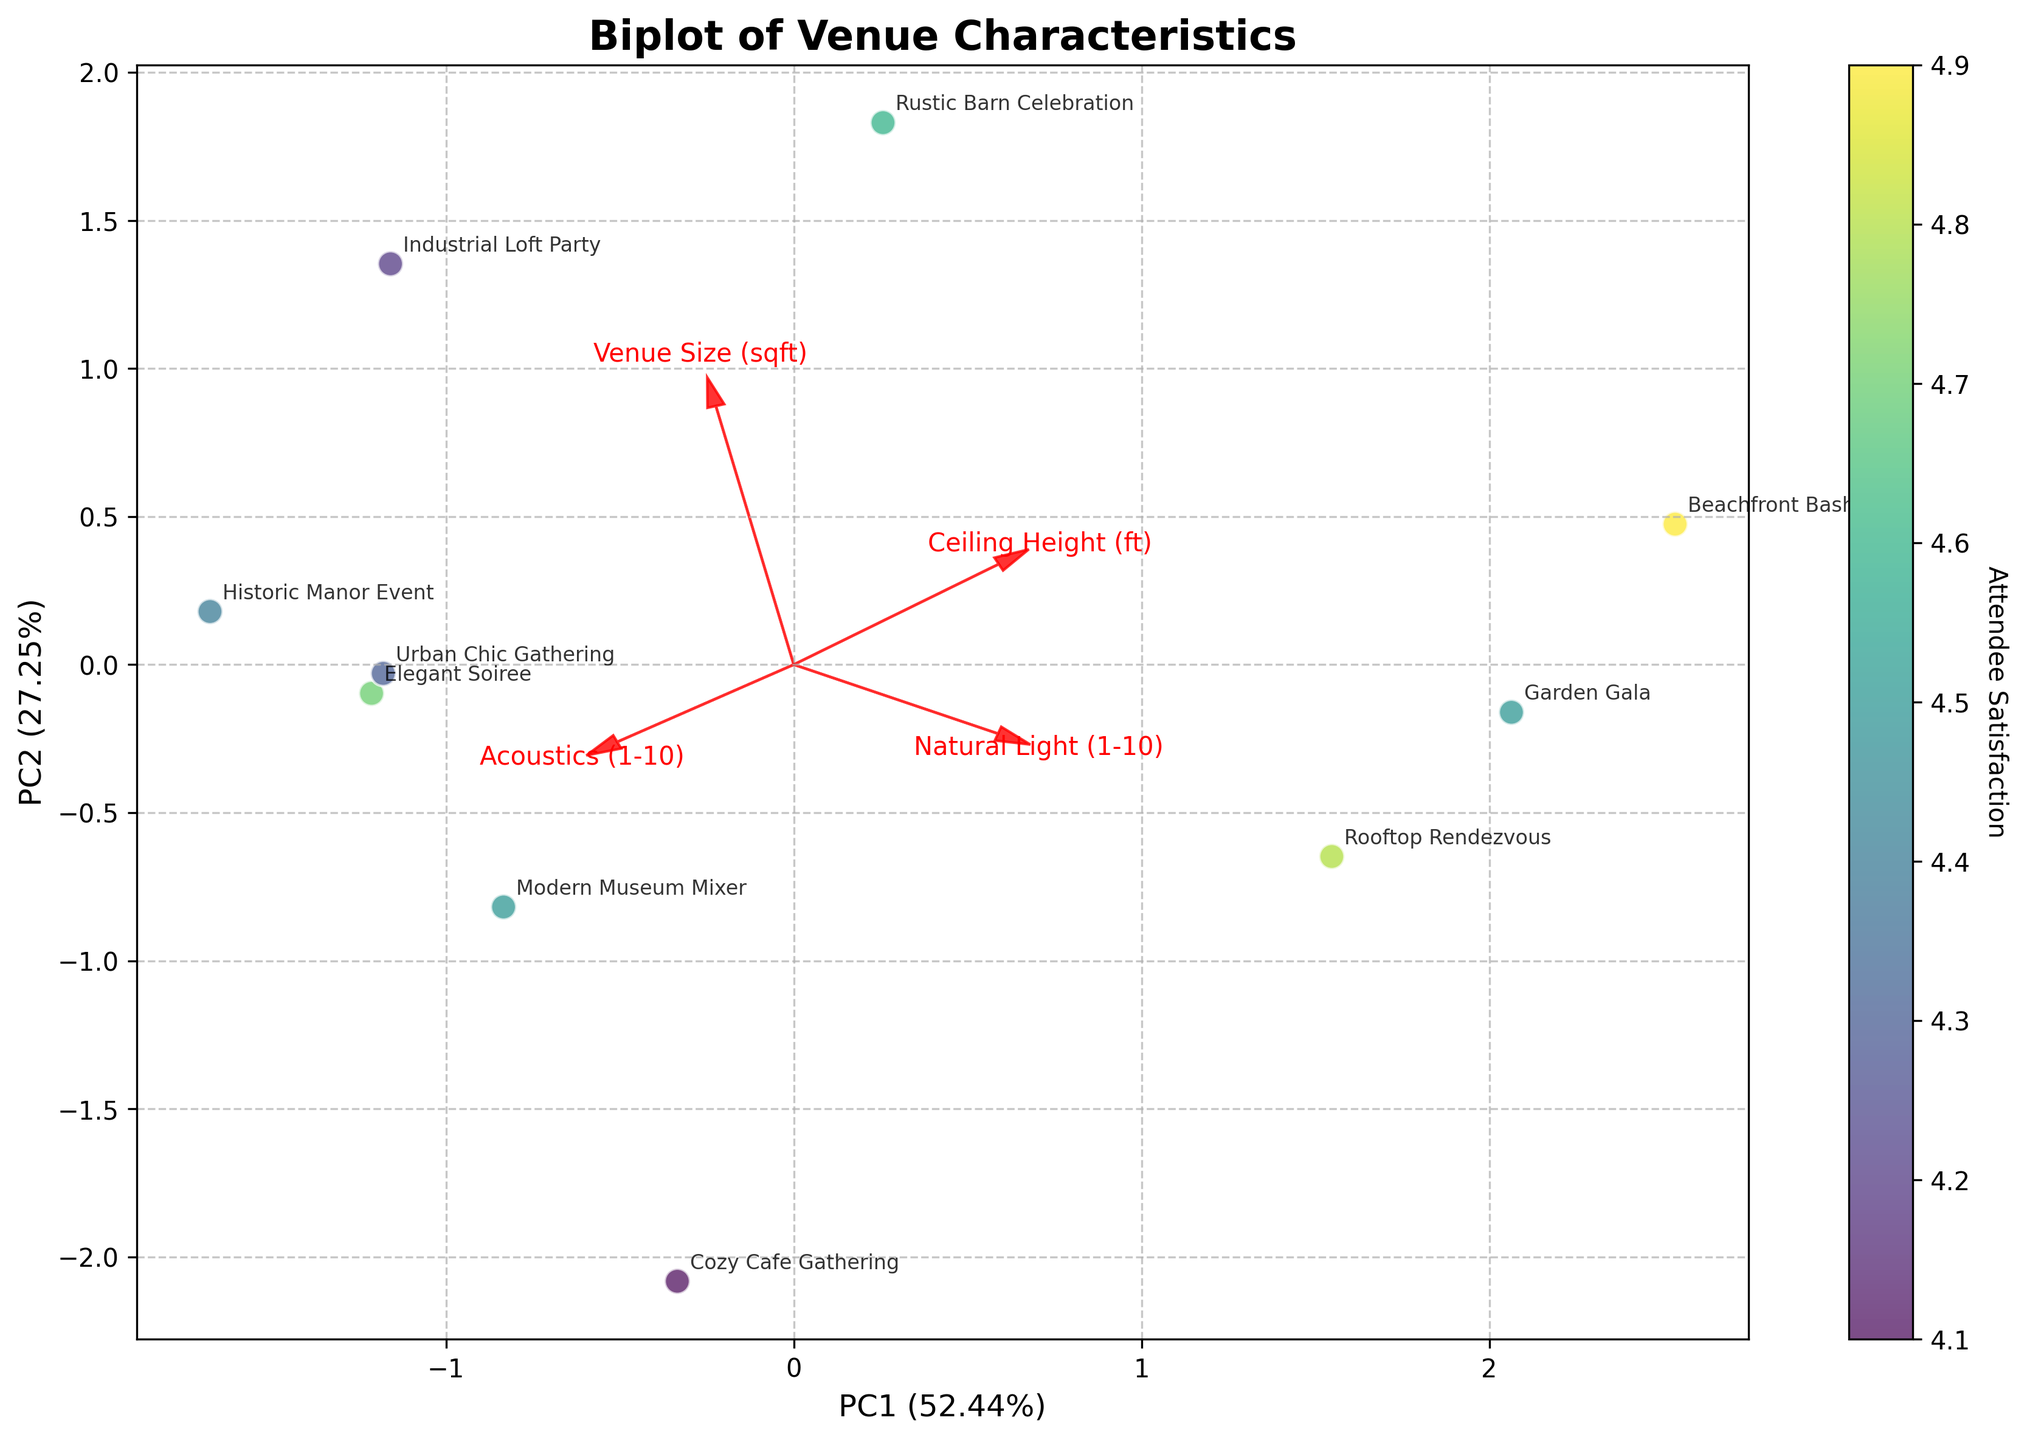What is the title of the figure? The title text is positioned at the top center of the figure, clearly labeled to describe the plot's purpose.
Answer: Biplot of Venue Characteristics How many arrows are displayed in the figure? Each arrow represents a feature vector and there are four distinct feature labels depicted in the plot.
Answer: Four arrows Which event has the highest attendee satisfaction, and where is it located on the plot? The color intensity of points indicates attendee satisfaction, with the highest values being the brightest. The label closest to the brightest point must be identified.
Answer: Beachfront Bash, located in the upper right section What does the X-axis represent, and what is its significance? Text next to the axis describes the explained variance ratio and properties of the principal component.
Answer: PC1 (49.43%) Which features are positively correlated based on the direction of the arrows? Features that point in the same direction indicate positive correlation.
Answer: Venue Size (sqft) and Ceiling Height (ft) Which venue has the lowest attendee satisfaction, and how is it represented on the plot? The point with the least intense color marks the lowest satisfaction, and its label indicates the event name.
Answer: Cozy Cafe Gathering, positioned towards the lower left Considering PC1 and PC2, which feature is most strongly associated with PC2? The length and direction of arrows reveal the contribution of features along each principal component.
Answer: Acoustics (1-10) How is 'Natural Light (1-10)' oriented in relation to the principal components? The angle and projection of the 'Natural Light (1-10)' arrow on the plot's axes are examined.
Answer: It is oriented more towards PC1 than PC2 How does 'Ceiling Height (ft)' affect revenue per attendee, and what does the biplot reveal about this relationship? Examining the association by the direction and length of the corresponding arrow relative to event points clustered by revenue.
Answer: Higher ceiling height appears positively correlated with both higher satisfaction and revenue per attendee Which events have similar PC score values, and how can you visually determine this from the plot? Proximity of plot points with annotated event names indicates similarity in their principal component scores.
Answer: Historic Manor Event and Urban Chic Gathering are close to each other in the plot How much variance do both principal components collectively explain in the data? The sum of explained variance ratios of both PC1 and PC2 can be derived from axis labels.
Answer: Approximately 83.48% 